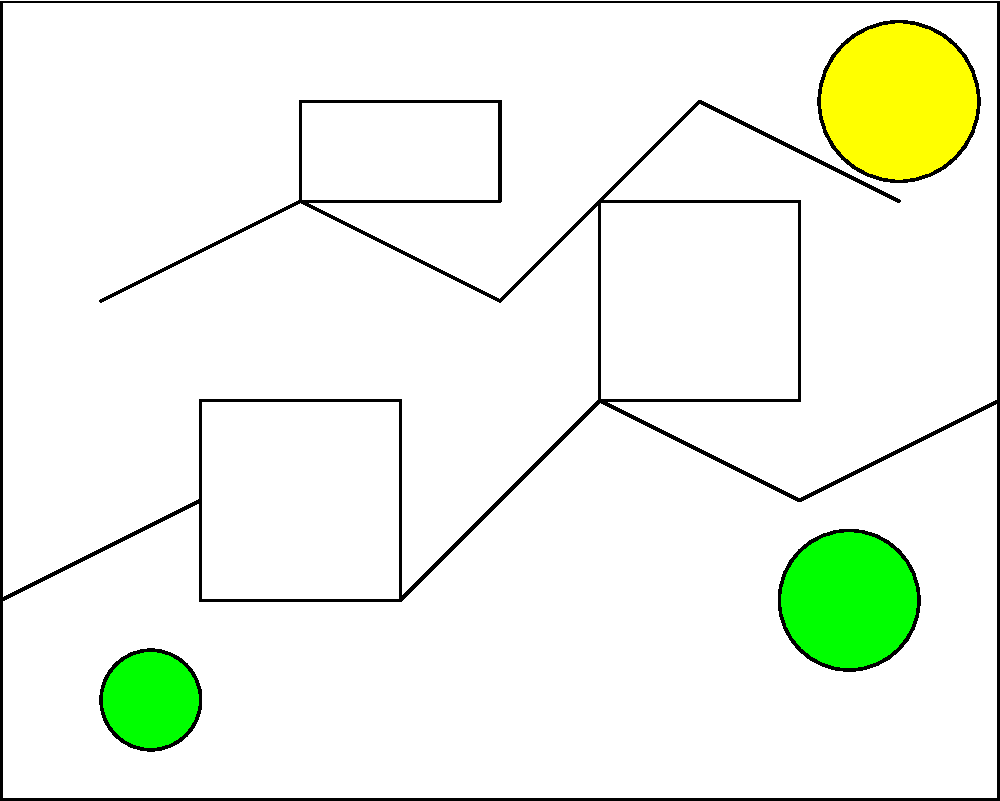As you gaze upon this fragmented landscape painting, reminiscent of the serene views your patients often describe, you notice three missing pieces. Based on the visible elements and the overall composition, which area of the painting is most likely to contain a continuation of the treeline? To answer this question, we need to analyze the composition of the landscape painting and consider the following steps:

1. Observe the existing elements:
   - There are two visible trees: one smaller tree on the left and a larger tree on the right.
   - A sun is visible in the upper right corner.
   - There's a horizon line with rolling hills or mountains.

2. Identify the missing pieces:
   - Piece 1: Center-left, lower portion of the painting
   - Piece 2: Center-right, middle portion of the painting
   - Piece 3: Upper-center portion of the painting

3. Analyze the composition:
   - The treeline is likely to continue along the horizon, following the contours of the hills or mountains.
   - Trees are typically found in the lower to middle portions of landscape paintings, grounding the composition.

4. Consider the balance of the painting:
   - With trees on both the left and right sides, it's logical that there might be more trees in the center to create a balanced composition.

5. Evaluate each missing piece:
   - Piece 1: Located in the lower-center, a suitable area for continuing the treeline.
   - Piece 2: In the middle-right, could potentially contain trees but less likely given the existing large tree nearby.
   - Piece 3: In the upper-center, too high to contain a continuation of the main treeline.

Given this analysis, the most likely area to contain a continuation of the treeline is Piece 1, located in the lower-center of the painting. This placement would create a natural flow and balance in the composition, connecting the existing trees and following the horizon line.
Answer: Piece 1 (lower-center) 